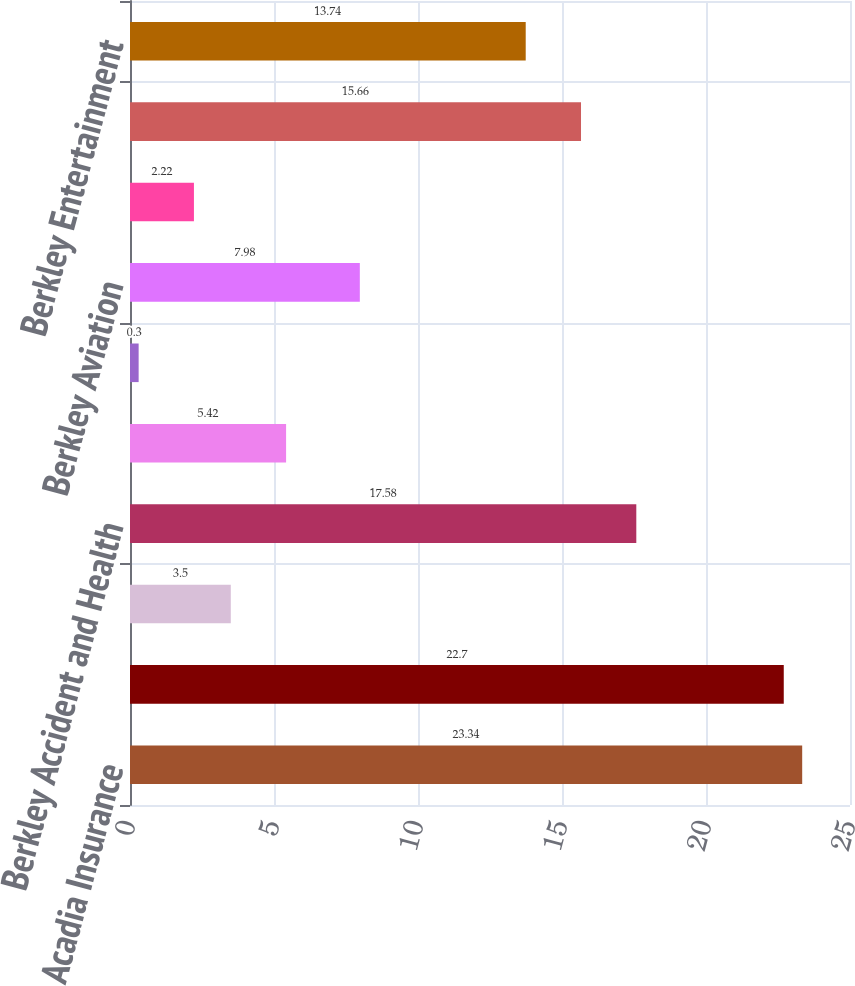<chart> <loc_0><loc_0><loc_500><loc_500><bar_chart><fcel>Acadia Insurance<fcel>Admiral Insurance<fcel>American Mining Insurance<fcel>Berkley Accident and Health<fcel>Berkley Agribusiness Risk<fcel>Berkley Aspire<fcel>Berkley Aviation<fcel>Berkley Canada<fcel>Berkley Custom Insurance<fcel>Berkley Entertainment<nl><fcel>23.34<fcel>22.7<fcel>3.5<fcel>17.58<fcel>5.42<fcel>0.3<fcel>7.98<fcel>2.22<fcel>15.66<fcel>13.74<nl></chart> 